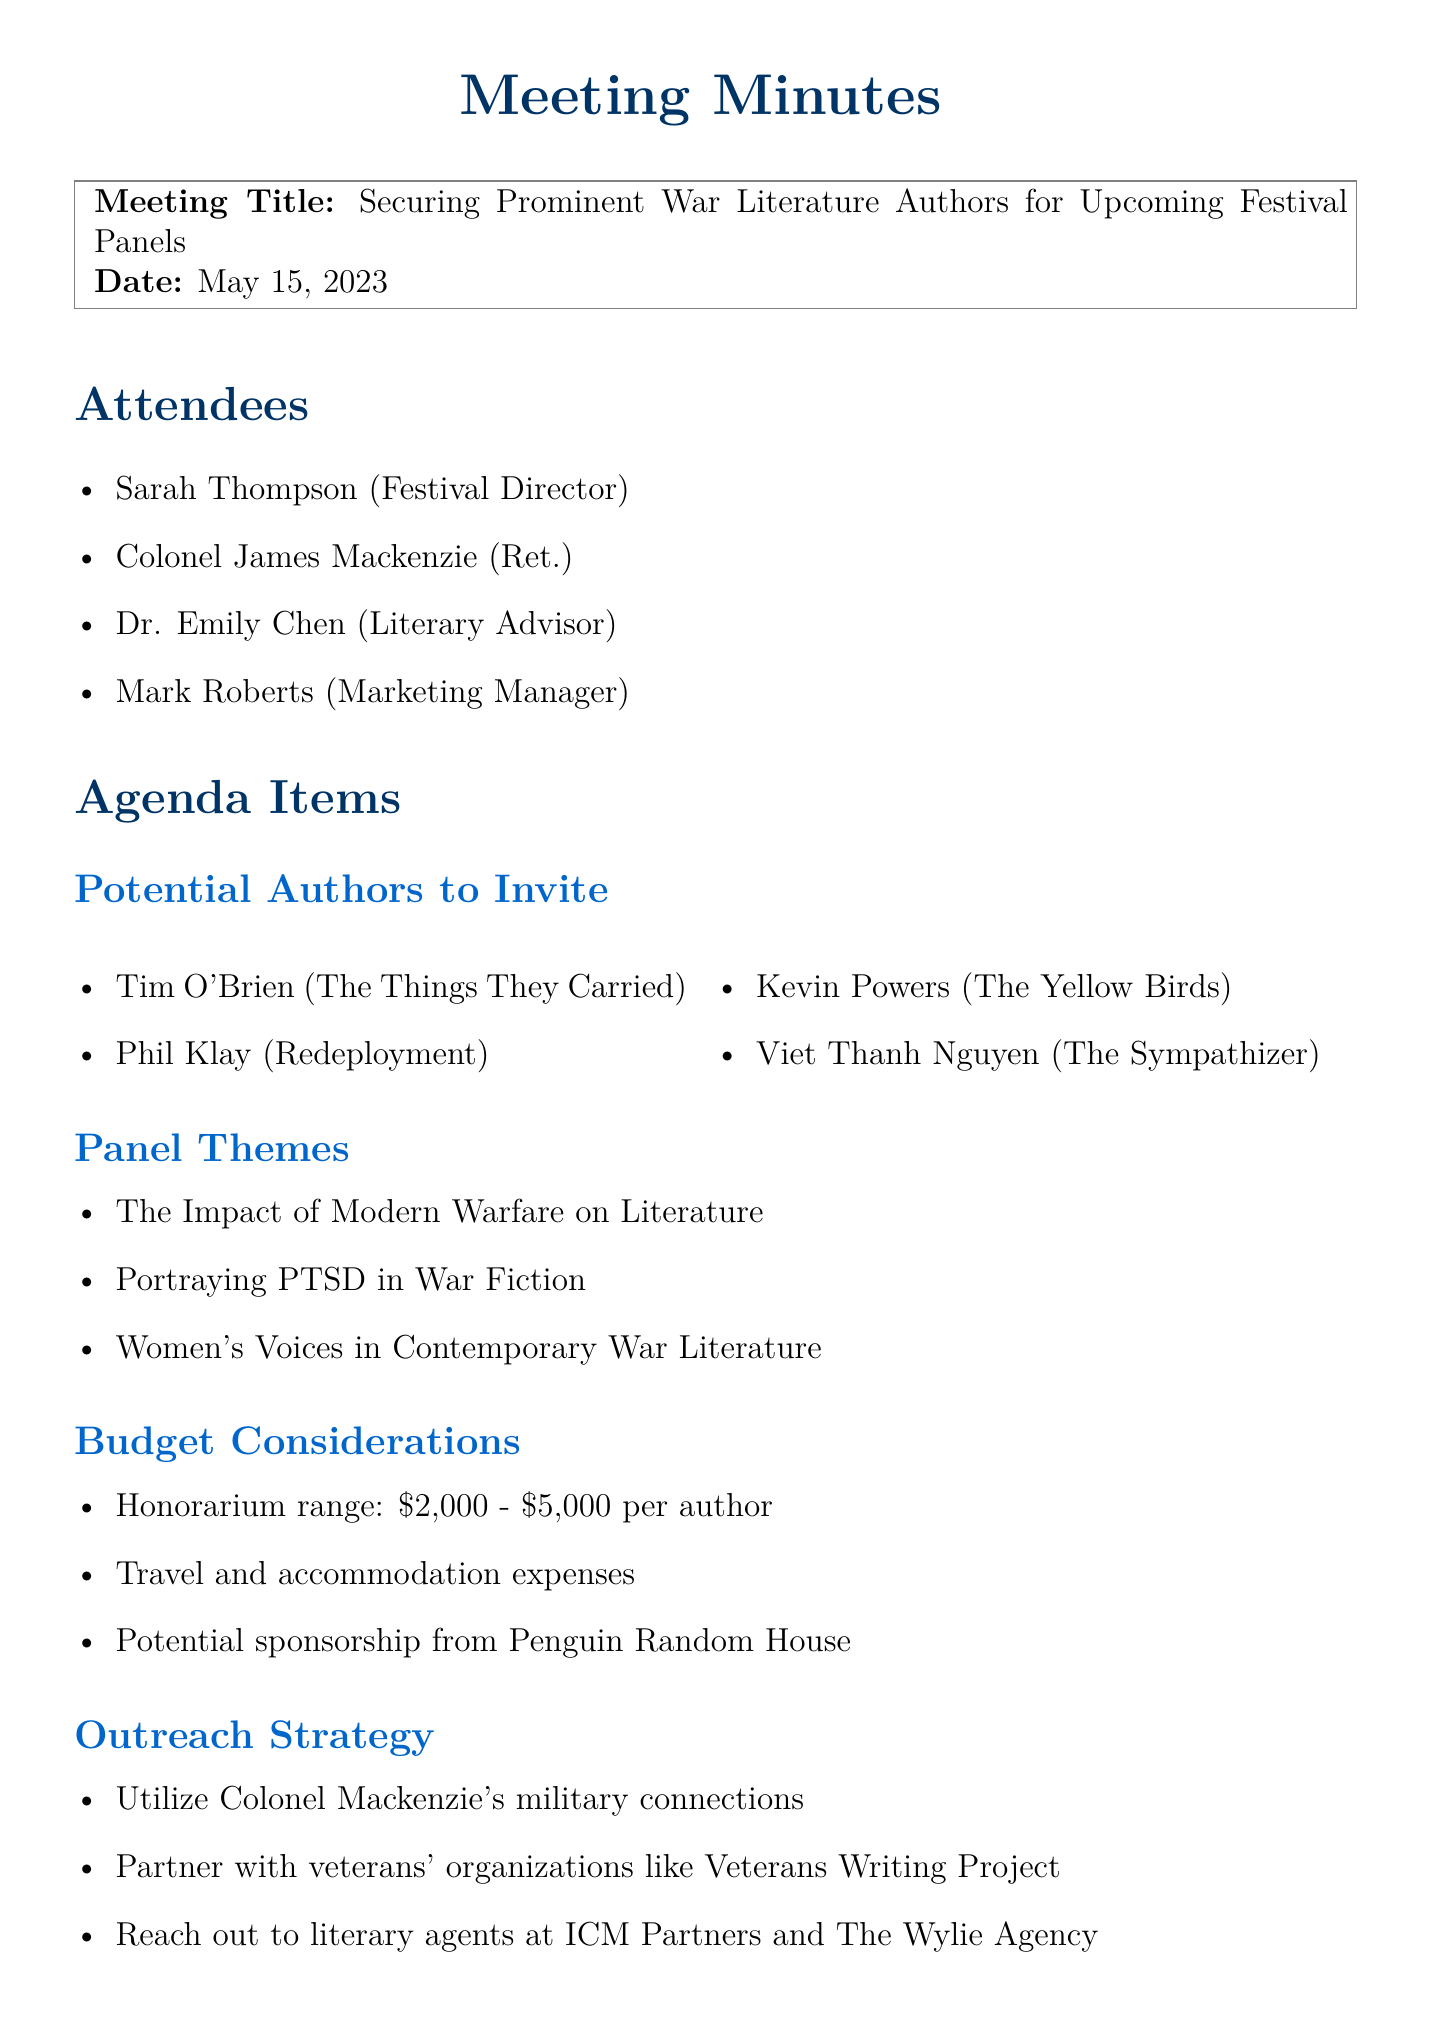What is the meeting title? The meeting title is stated in the document as "Securing Prominent War Literature Authors for Upcoming Festival Panels."
Answer: Securing Prominent War Literature Authors for Upcoming Festival Panels Who is the Festival Director? The name and role of the Festival Director are provided in the attendees section of the document.
Answer: Sarah Thompson What is the honorarium range per author? The document specifies the range for the honorarium in the budget considerations section.
Answer: $2,000 - $5,000 When is the deadline to send invitations? The timeline section outlines the deadlines for various actions, including sending invitations.
Answer: June 1st Which author wrote "The Things They Carried"? The document lists potential authors to invite and identifies who wrote that specific work.
Answer: Tim O'Brien How many panel themes are discussed in the meeting? The number of themes is found in the agenda under the panel themes section.
Answer: Three What strategy is suggested to utilize Colonel Mackenzie's connections? The outreach strategy section outlines the plan to utilize Colonel Mackenzie’s connections.
Answer: Military connections Who is responsible for drafting invitation letters? The action items section states who will be responsible for this task.
Answer: Sarah 